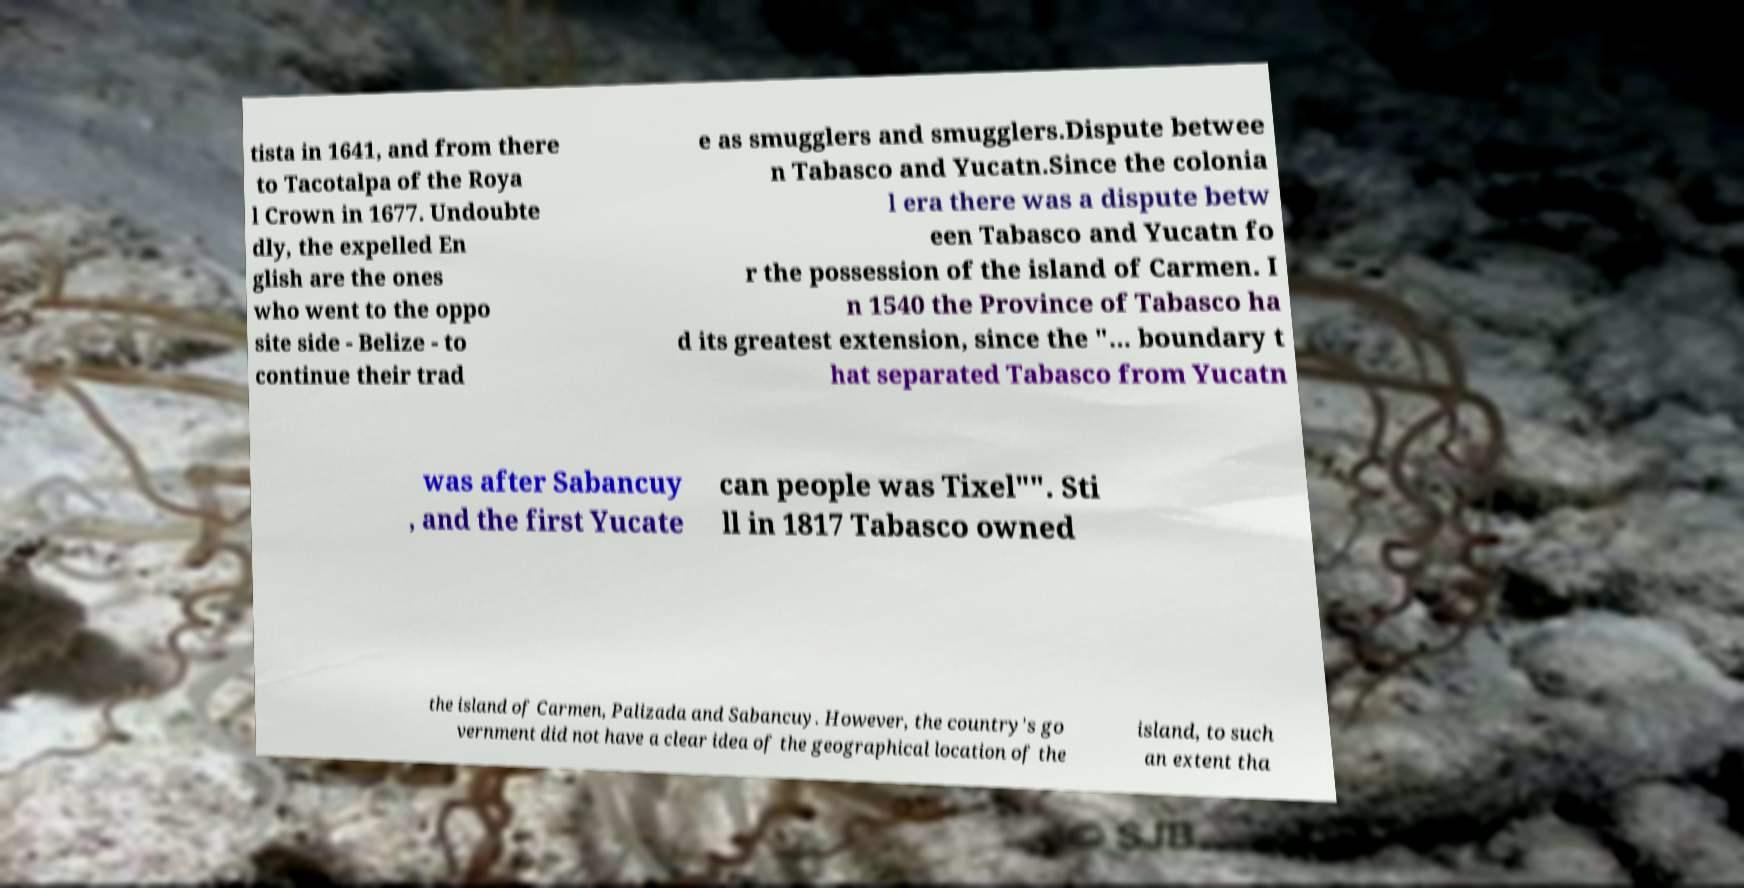Could you assist in decoding the text presented in this image and type it out clearly? tista in 1641, and from there to Tacotalpa of the Roya l Crown in 1677. Undoubte dly, the expelled En glish are the ones who went to the oppo site side - Belize - to continue their trad e as smugglers and smugglers.Dispute betwee n Tabasco and Yucatn.Since the colonia l era there was a dispute betw een Tabasco and Yucatn fo r the possession of the island of Carmen. I n 1540 the Province of Tabasco ha d its greatest extension, since the "... boundary t hat separated Tabasco from Yucatn was after Sabancuy , and the first Yucate can people was Tixel"". Sti ll in 1817 Tabasco owned the island of Carmen, Palizada and Sabancuy. However, the country's go vernment did not have a clear idea of the geographical location of the island, to such an extent tha 